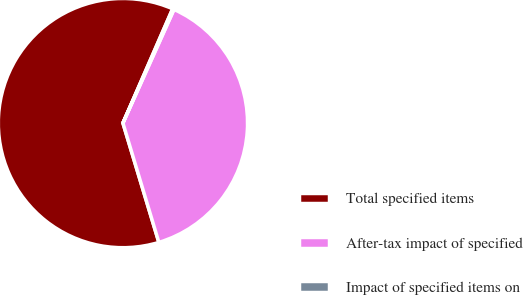Convert chart. <chart><loc_0><loc_0><loc_500><loc_500><pie_chart><fcel>Total specified items<fcel>After-tax impact of specified<fcel>Impact of specified items on<nl><fcel>61.18%<fcel>38.62%<fcel>0.19%<nl></chart> 